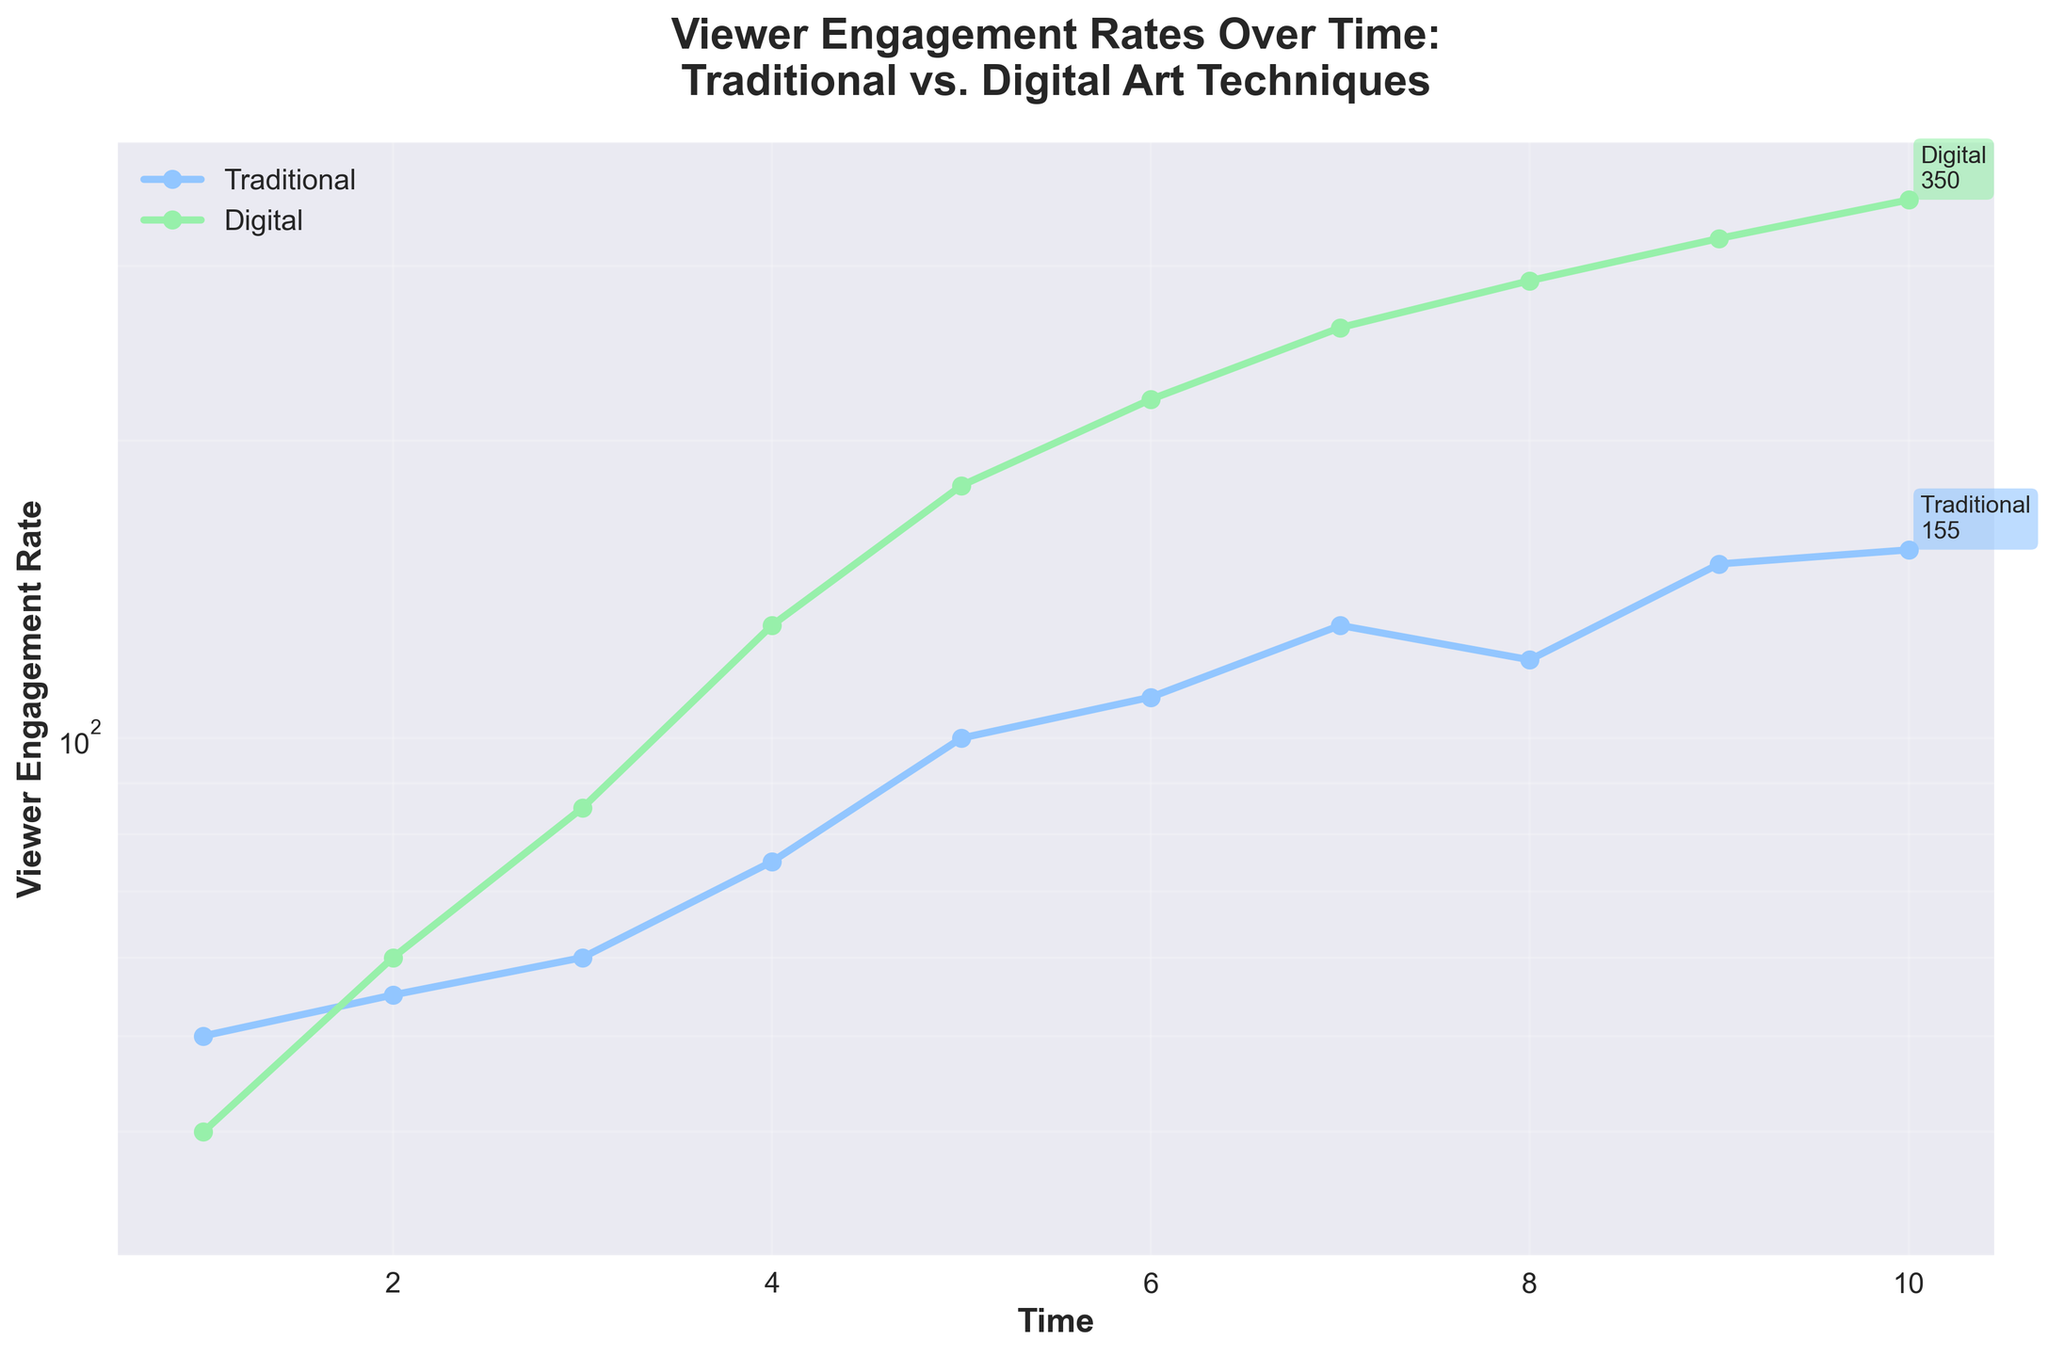what is the title of the plot? The title of the plot is written at the top of the figure in bold font. It reads "Viewer Engagement Rates Over Time:\nTraditional vs. Digital Art Techniques".
Answer: Viewer Engagement Rates Over Time:\nTraditional vs. Digital Art Techniques What are the time units on the x-axis in the plot? The x-axis of the plot is labeled 'Time', and the ticks indicate time units from 1 to 10. These are evenly spaced.
Answer: 1 to 10 Which technique has the higher final Viewer Engagement Rate? The final Viewer Engagement Rate is indicated by the last point on each line. The Digital technique ends at a higher value, marked as 350, while the Traditional technique ends at 155.
Answer: Digital What is the average Viewer Engagement Rate of the Digital technique at times 1, 5, and 10? The Viewer Engagement Rates for the Digital technique at times 1, 5, and 10 are 40, 180, and 350, respectively. To find the average, sum these values (40 + 180 + 350 = 570) and divide by 3, resulting in 190.
Answer: 190 How many peaks are observed in the Viewer Engagement Rate for the Traditional technique? The Traditional technique shows peaks where the Viewer Engagement Rate increases to a local maximum. By observing the line, one peak can be identified around time 7 where the rate reaches 130 before dipping again.
Answer: 1 At which time point does the Traditional technique surpass a Viewer Engagement Rate of 100 for the first time? Looking at the data points on the log-scaled y-axis, the Traditional technique first surpasses a Viewer Engagement Rate of 100 at time 5.
Answer: 5 What is the difference in Viewer Engagement Rates between the Traditional and Digital techniques at time 4? At time 4, the Viewer Engagement Rate for the Traditional technique is 75, and for the Digital technique, it is 130. The difference is 130 - 75 = 55.
Answer: 55 Which technique shows a more significant increase in engagement rate between time 1 and time 5? From time 1 to time 5, the Traditional technique increases from 50 to 100 (50 units), while the Digital technique increases from 40 to 180 (140 units). Thus, the Digital technique shows a more significant increase.
Answer: Digital Over what range of times does the Digital technique's Viewer Engagement Rate exceed that of the Traditional technique? By observing the plot and comparing both lines, the Digital technique exceeds the Traditional technique in terms of Viewer Engagement Rate from time 2 onward.
Answer: 2 to 10 